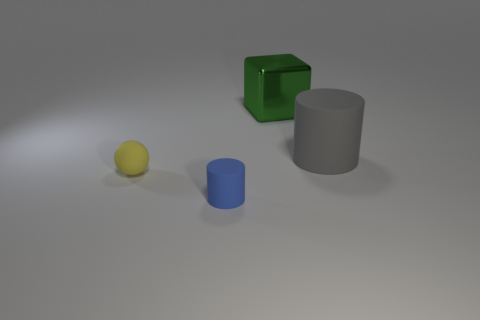Add 4 yellow cylinders. How many objects exist? 8 Subtract all balls. How many objects are left? 3 Subtract all gray rubber objects. Subtract all green shiny cubes. How many objects are left? 2 Add 3 gray things. How many gray things are left? 4 Add 2 big metal cubes. How many big metal cubes exist? 3 Subtract 0 yellow cylinders. How many objects are left? 4 